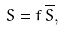<formula> <loc_0><loc_0><loc_500><loc_500>S = f \, \overline { S } ,</formula> 